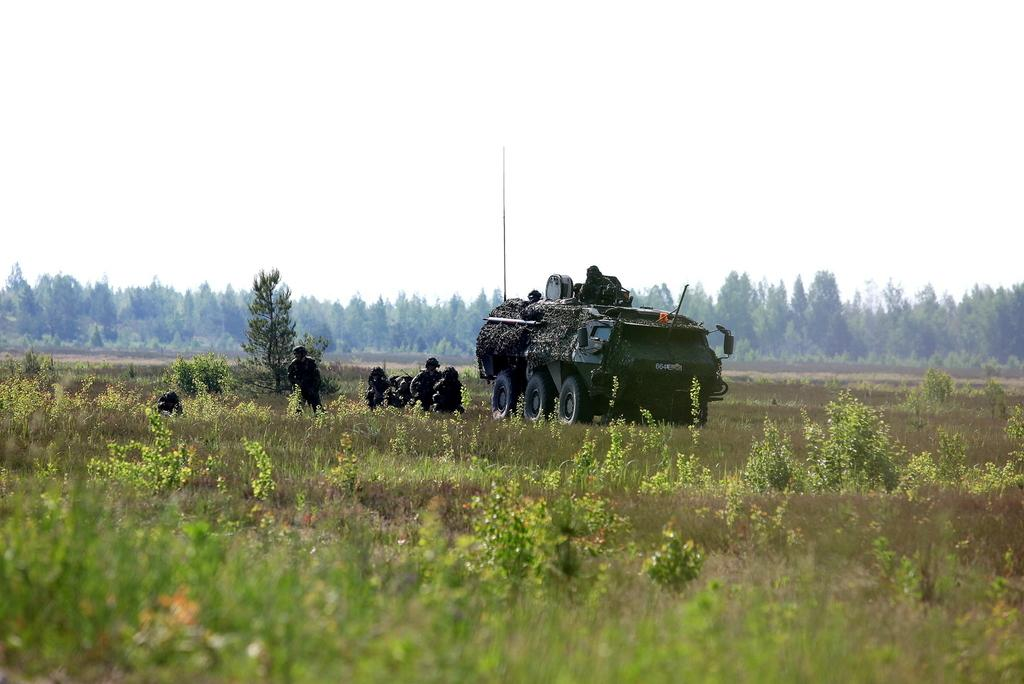What is the main subject of the image? There is a vehicle in the image. What else can be seen in the image besides the vehicle? There are persons on the ground in the image. What can be seen in the background of the image? There are trees and the sky visible in the background of the image. What is the reason for the shock in the image? There is no shock or any indication of a shocking event in the image. 